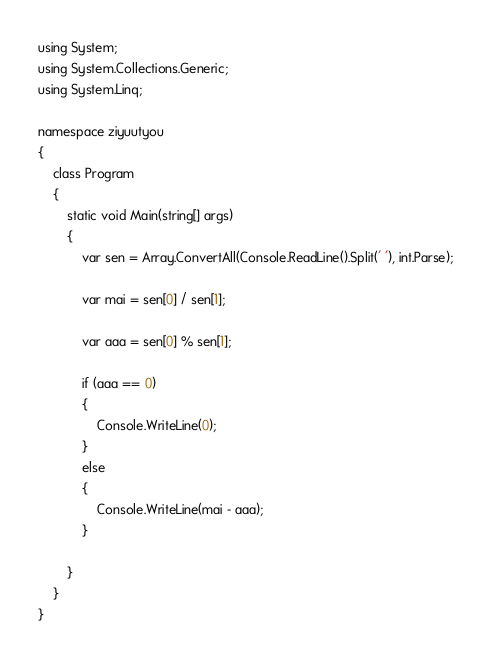Convert code to text. <code><loc_0><loc_0><loc_500><loc_500><_C#_>using System;
using System.Collections.Generic;
using System.Linq;

namespace ziyuutyou
{
    class Program
    {
        static void Main(string[] args)
        {
            var sen = Array.ConvertAll(Console.ReadLine().Split(' '), int.Parse);

            var mai = sen[0] / sen[1];

            var aaa = sen[0] % sen[1];

            if (aaa == 0)
            {
                Console.WriteLine(0);
            }
            else
            {
                Console.WriteLine(mai - aaa);
            }
            
        }
    }
}
</code> 